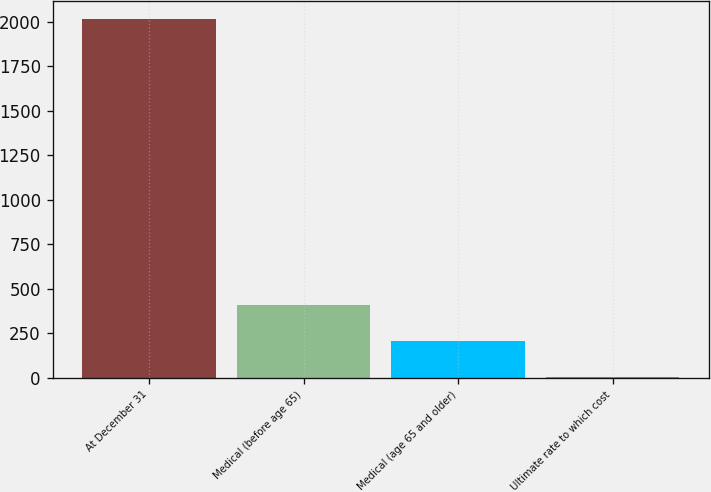<chart> <loc_0><loc_0><loc_500><loc_500><bar_chart><fcel>At December 31<fcel>Medical (before age 65)<fcel>Medical (age 65 and older)<fcel>Ultimate rate to which cost<nl><fcel>2016<fcel>406.8<fcel>205.65<fcel>4.5<nl></chart> 